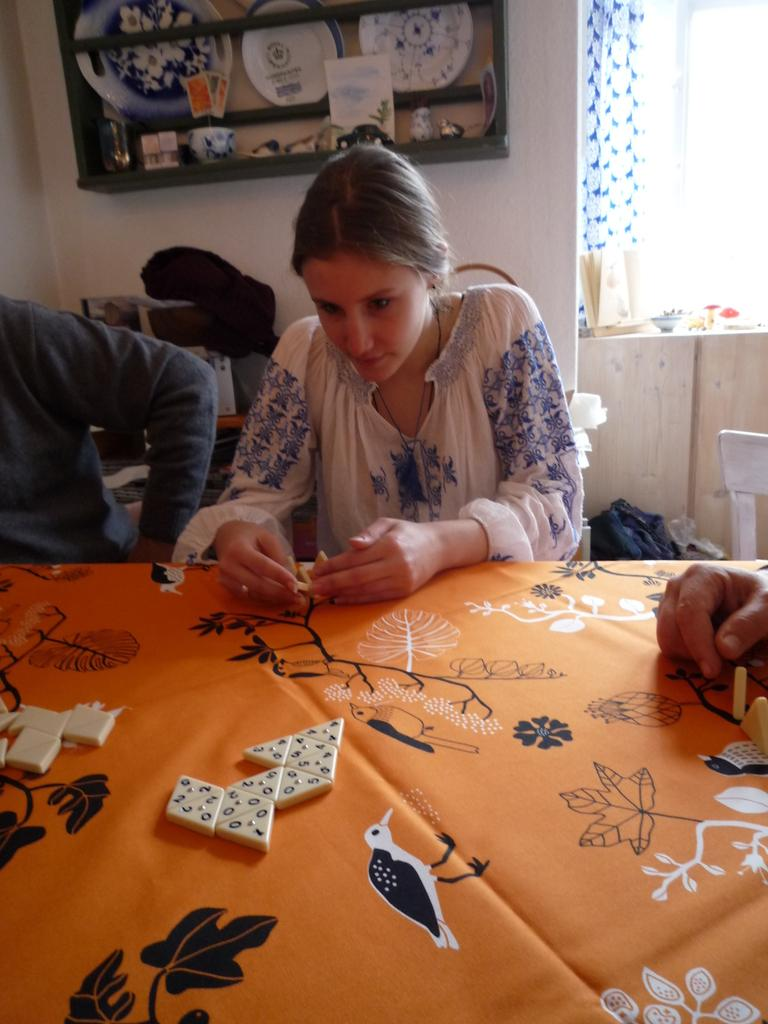How many people are seated in the image? There are two people seated in the image. What is the woman in the image doing? The woman is playing a game in the image. What can be seen behind the woman? There is a shelf visible behind the woman. Can you see a wheel attached to the chair the woman is sitting on in the image? There is no wheel visible on the chair the woman is sitting on in the image. What phase of the moon is visible in the image? The moon is not visible in the image. 